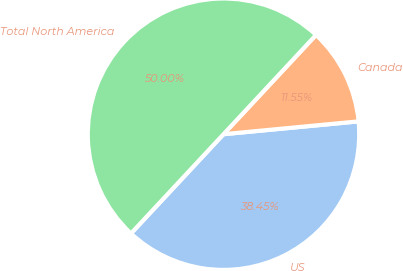Convert chart. <chart><loc_0><loc_0><loc_500><loc_500><pie_chart><fcel>US<fcel>Canada<fcel>Total North America<nl><fcel>38.45%<fcel>11.55%<fcel>50.0%<nl></chart> 